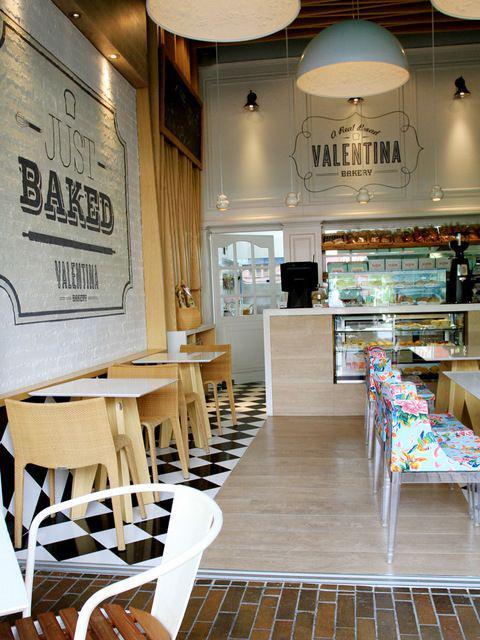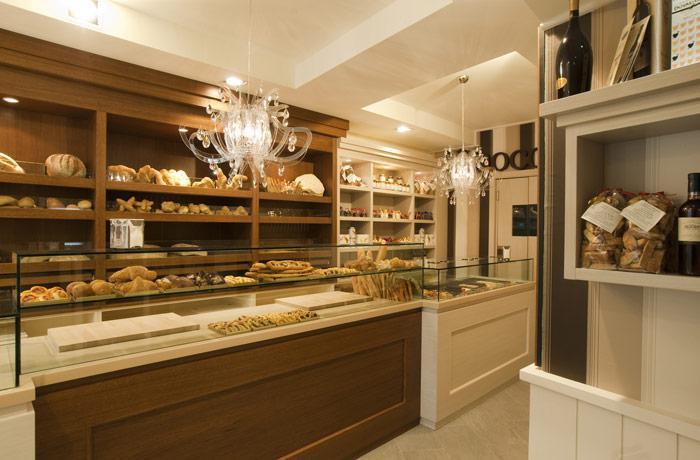The first image is the image on the left, the second image is the image on the right. Examine the images to the left and right. Is the description "Right image shows a bakery with pale green display cases and black track lighting suspended from a wood plank ceiling." accurate? Answer yes or no. No. The first image is the image on the left, the second image is the image on the right. For the images displayed, is the sentence "There is at least one square table with chairs inside a bakery." factually correct? Answer yes or no. Yes. 